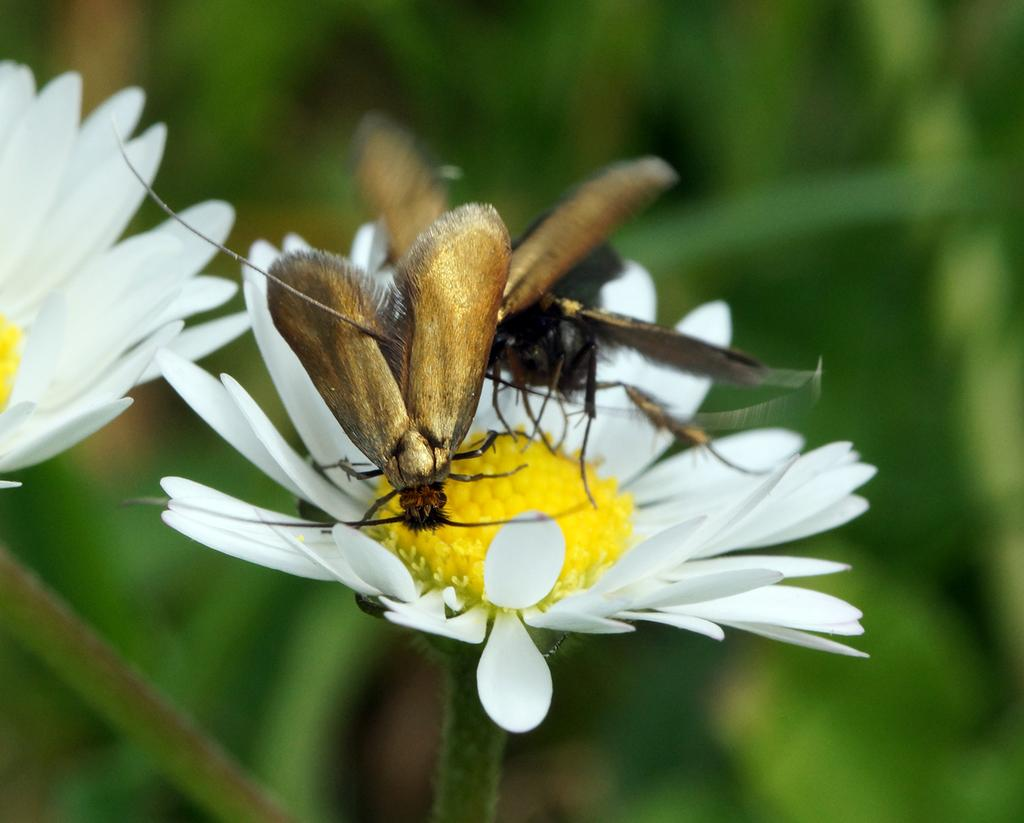What is happening on the flower in the image? There are two insects on a flower in the image. Can you describe the other flower in the image? There is another flower on the left side of the image. What can be observed about the background of the image? The background of the image is blurred. What type of door can be seen in the image? There is no door present in the image; it features insects on a flower and another flower in the background. 